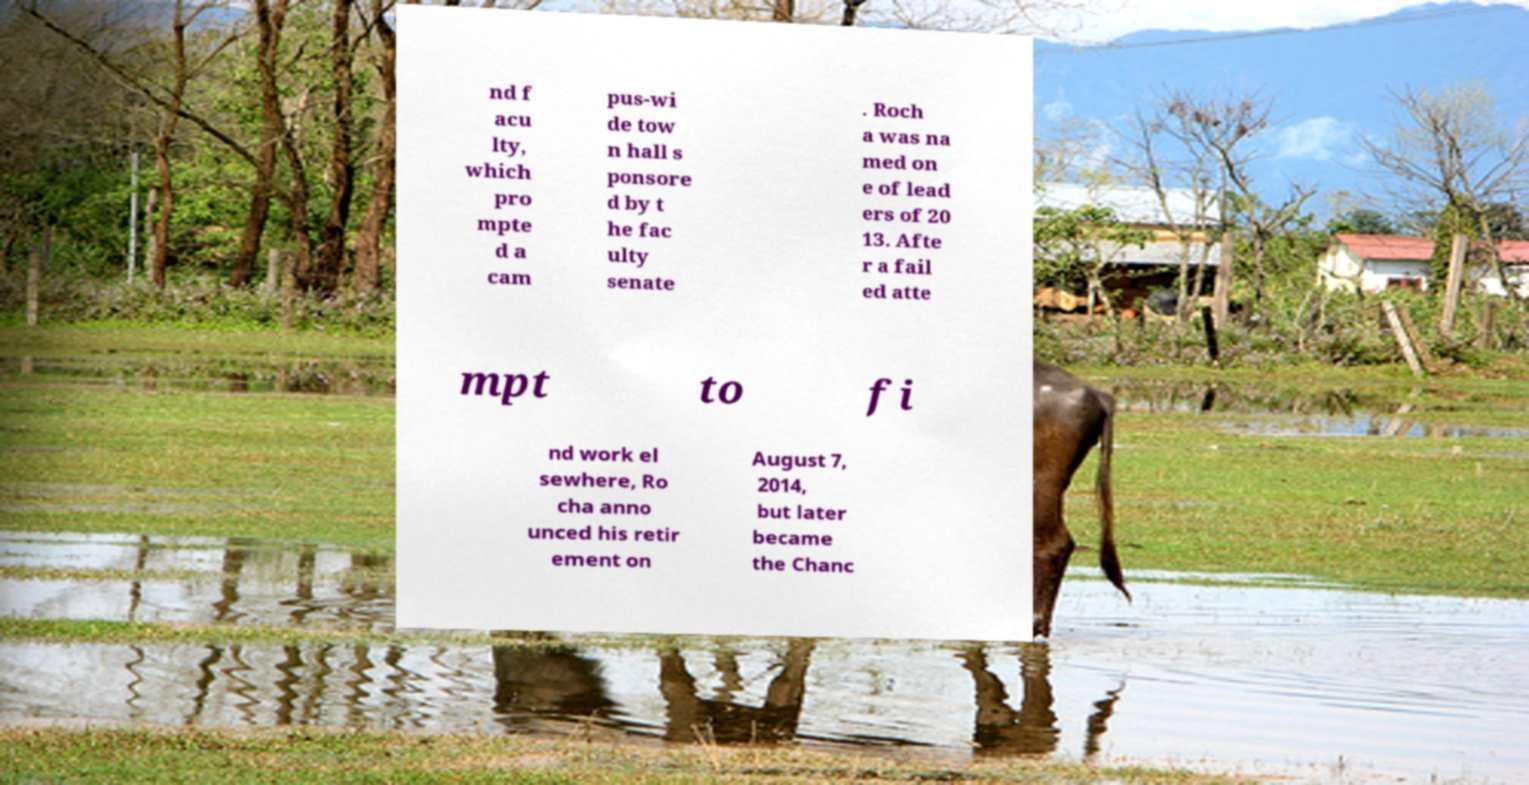Please read and relay the text visible in this image. What does it say? nd f acu lty, which pro mpte d a cam pus-wi de tow n hall s ponsore d by t he fac ulty senate . Roch a was na med on e of lead ers of 20 13. Afte r a fail ed atte mpt to fi nd work el sewhere, Ro cha anno unced his retir ement on August 7, 2014, but later became the Chanc 